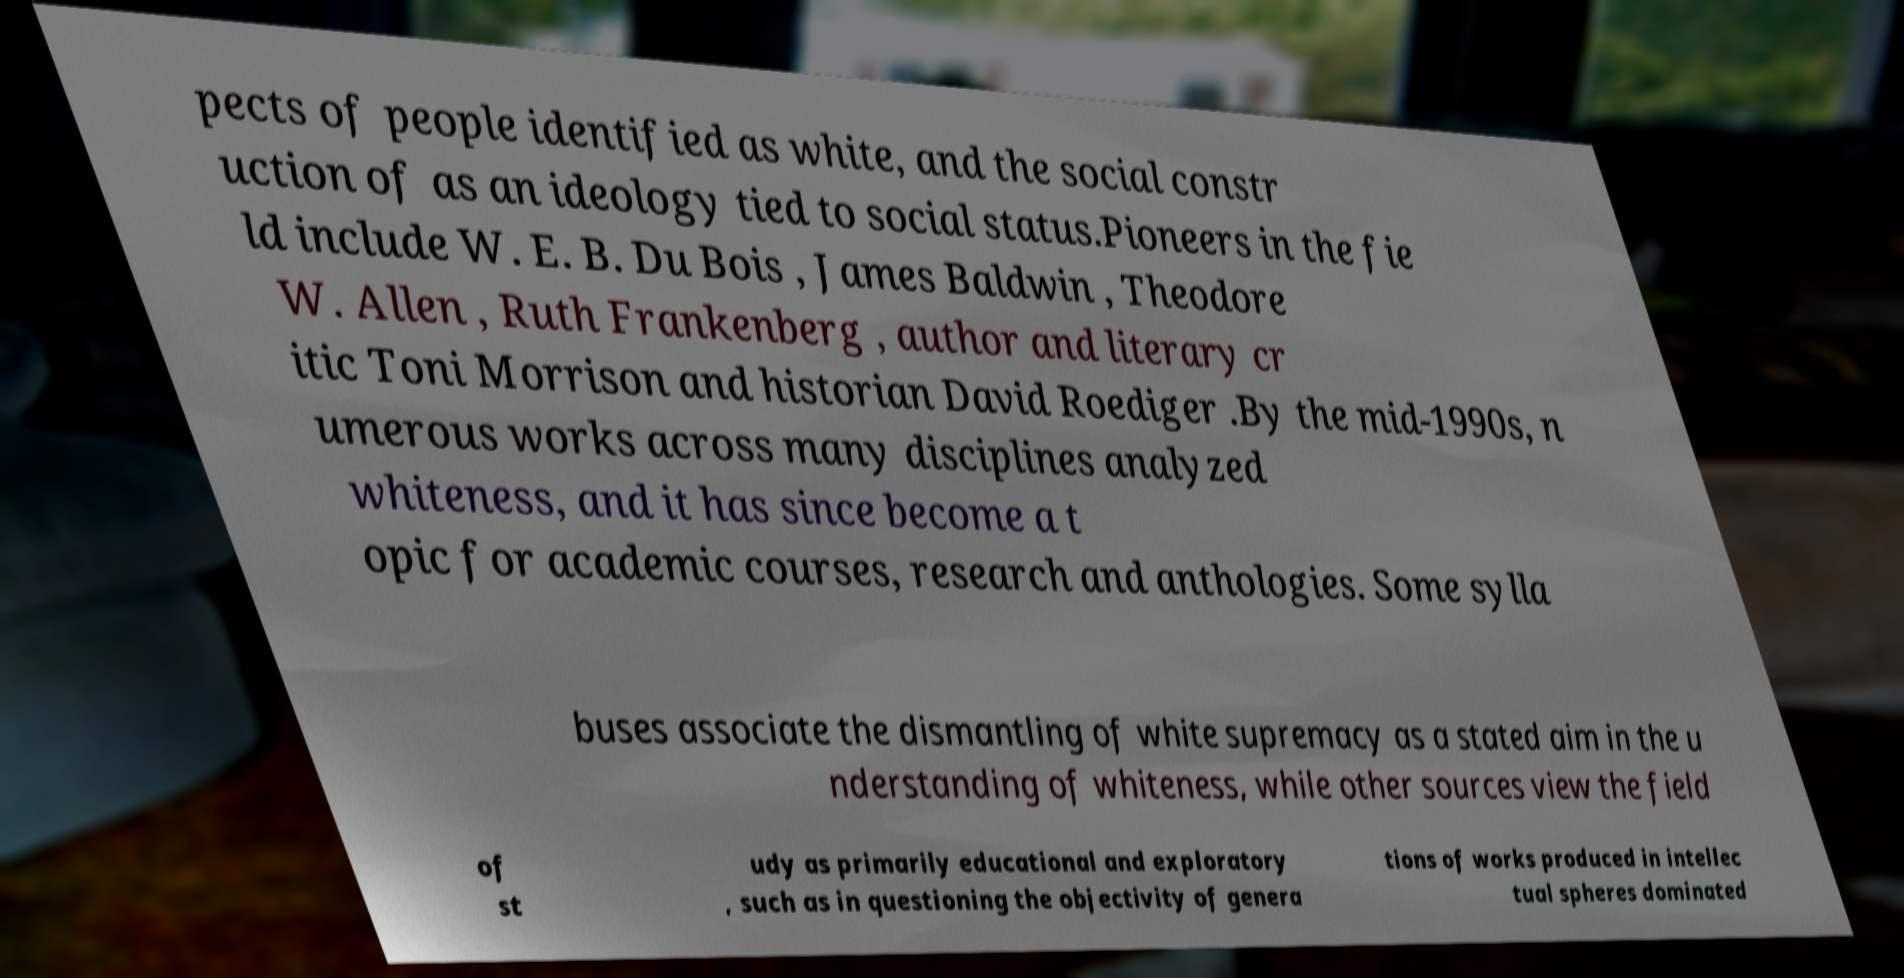Please read and relay the text visible in this image. What does it say? pects of people identified as white, and the social constr uction of as an ideology tied to social status.Pioneers in the fie ld include W. E. B. Du Bois , James Baldwin , Theodore W. Allen , Ruth Frankenberg , author and literary cr itic Toni Morrison and historian David Roediger .By the mid-1990s, n umerous works across many disciplines analyzed whiteness, and it has since become a t opic for academic courses, research and anthologies. Some sylla buses associate the dismantling of white supremacy as a stated aim in the u nderstanding of whiteness, while other sources view the field of st udy as primarily educational and exploratory , such as in questioning the objectivity of genera tions of works produced in intellec tual spheres dominated 